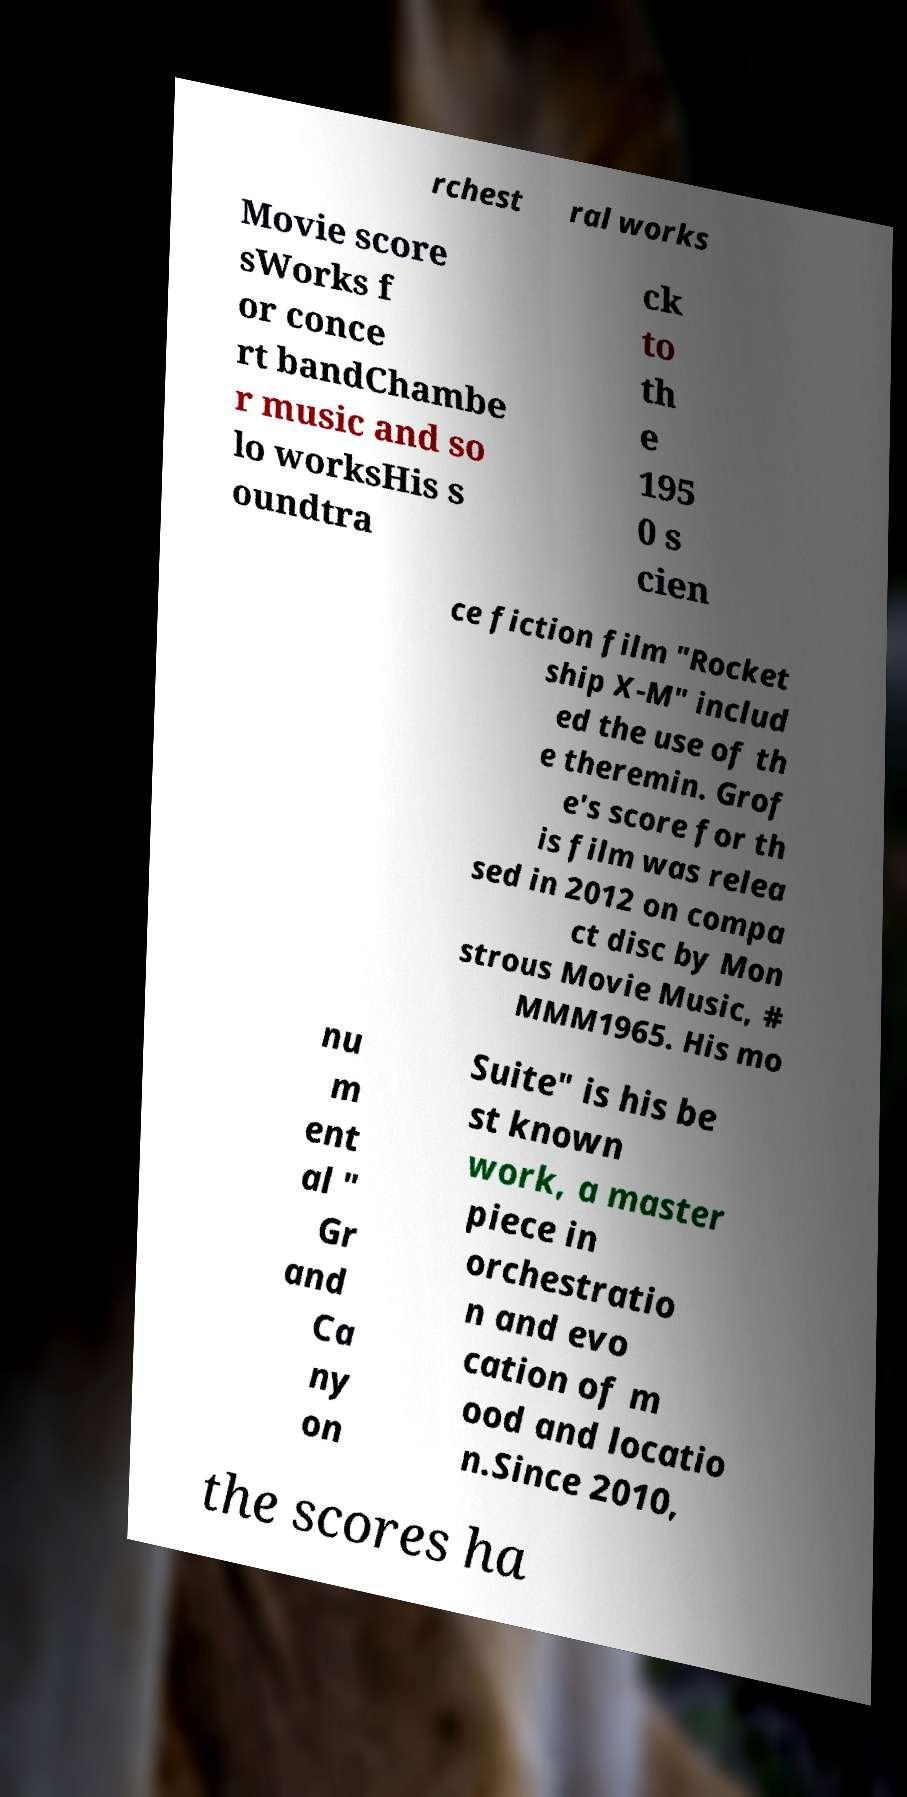What messages or text are displayed in this image? I need them in a readable, typed format. rchest ral works Movie score sWorks f or conce rt bandChambe r music and so lo worksHis s oundtra ck to th e 195 0 s cien ce fiction film "Rocket ship X-M" includ ed the use of th e theremin. Grof e's score for th is film was relea sed in 2012 on compa ct disc by Mon strous Movie Music, # MMM1965. His mo nu m ent al " Gr and Ca ny on Suite" is his be st known work, a master piece in orchestratio n and evo cation of m ood and locatio n.Since 2010, the scores ha 